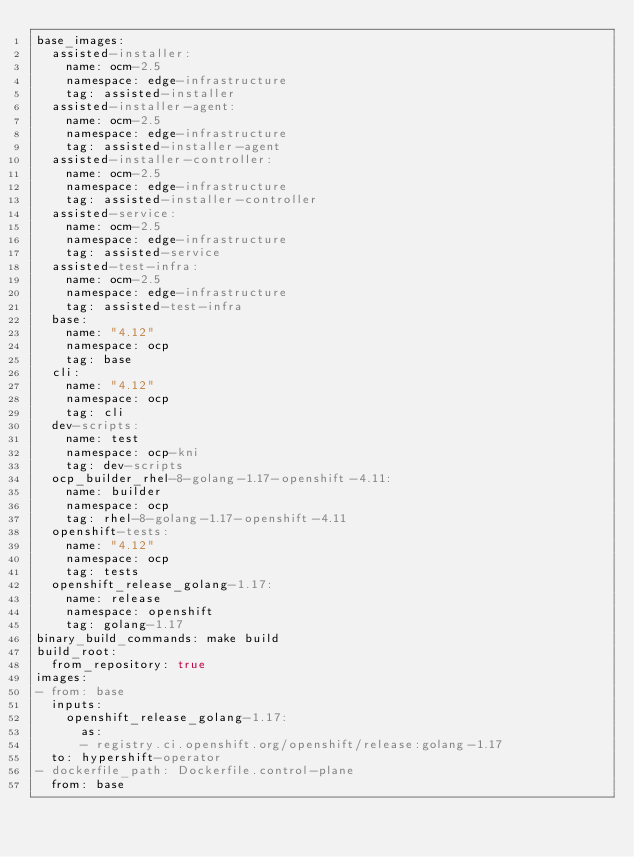<code> <loc_0><loc_0><loc_500><loc_500><_YAML_>base_images:
  assisted-installer:
    name: ocm-2.5
    namespace: edge-infrastructure
    tag: assisted-installer
  assisted-installer-agent:
    name: ocm-2.5
    namespace: edge-infrastructure
    tag: assisted-installer-agent
  assisted-installer-controller:
    name: ocm-2.5
    namespace: edge-infrastructure
    tag: assisted-installer-controller
  assisted-service:
    name: ocm-2.5
    namespace: edge-infrastructure
    tag: assisted-service
  assisted-test-infra:
    name: ocm-2.5
    namespace: edge-infrastructure
    tag: assisted-test-infra
  base:
    name: "4.12"
    namespace: ocp
    tag: base
  cli:
    name: "4.12"
    namespace: ocp
    tag: cli
  dev-scripts:
    name: test
    namespace: ocp-kni
    tag: dev-scripts
  ocp_builder_rhel-8-golang-1.17-openshift-4.11:
    name: builder
    namespace: ocp
    tag: rhel-8-golang-1.17-openshift-4.11
  openshift-tests:
    name: "4.12"
    namespace: ocp
    tag: tests
  openshift_release_golang-1.17:
    name: release
    namespace: openshift
    tag: golang-1.17
binary_build_commands: make build
build_root:
  from_repository: true
images:
- from: base
  inputs:
    openshift_release_golang-1.17:
      as:
      - registry.ci.openshift.org/openshift/release:golang-1.17
  to: hypershift-operator
- dockerfile_path: Dockerfile.control-plane
  from: base</code> 